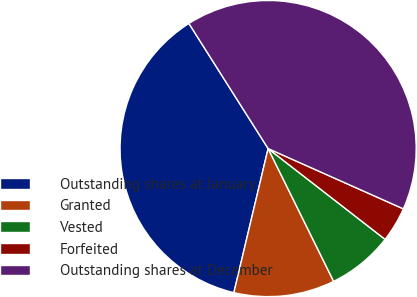Convert chart. <chart><loc_0><loc_0><loc_500><loc_500><pie_chart><fcel>Outstanding shares at January<fcel>Granted<fcel>Vested<fcel>Forfeited<fcel>Outstanding shares at December<nl><fcel>37.3%<fcel>11.01%<fcel>7.2%<fcel>3.83%<fcel>40.66%<nl></chart> 